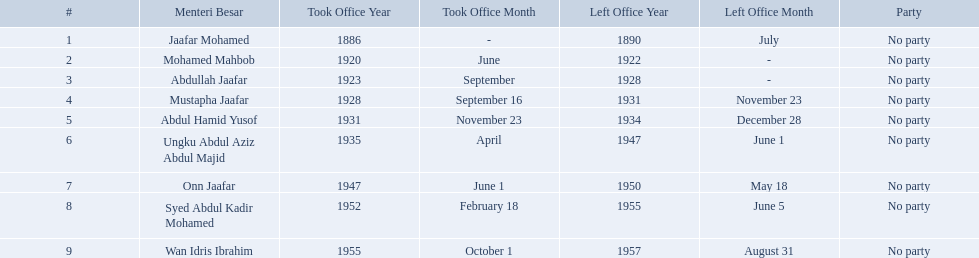Who were the menteri besar of johor? Jaafar Mohamed, Mohamed Mahbob, Abdullah Jaafar, Mustapha Jaafar, Abdul Hamid Yusof, Ungku Abdul Aziz Abdul Majid, Onn Jaafar, Syed Abdul Kadir Mohamed, Wan Idris Ibrahim. Who served the longest? Ungku Abdul Aziz Abdul Majid. Who are all of the menteri besars? Jaafar Mohamed, Mohamed Mahbob, Abdullah Jaafar, Mustapha Jaafar, Abdul Hamid Yusof, Ungku Abdul Aziz Abdul Majid, Onn Jaafar, Syed Abdul Kadir Mohamed, Wan Idris Ibrahim. When did each take office? 1886, June 1920, September 1923, September 16, 1928, November 23, 1931, April 1935, June 1, 1947, February 18, 1952, October 1, 1955. When did they leave? July 1890, 1922, 1928, November 23, 1931, December 28, 1934, June 1, 1947, May 18, 1950, June 5, 1955, August 31, 1957. And which spent the most time in office? Ungku Abdul Aziz Abdul Majid. When did jaafar mohamed take office? 1886. When did mohamed mahbob take office? June 1920. Who was in office no more than 4 years? Mohamed Mahbob. Who were all of the menteri besars? Jaafar Mohamed, Mohamed Mahbob, Abdullah Jaafar, Mustapha Jaafar, Abdul Hamid Yusof, Ungku Abdul Aziz Abdul Majid, Onn Jaafar, Syed Abdul Kadir Mohamed, Wan Idris Ibrahim. When did they take office? 1886, June 1920, September 1923, September 16, 1928, November 23, 1931, April 1935, June 1, 1947, February 18, 1952, October 1, 1955. And when did they leave? July 1890, 1922, 1928, November 23, 1931, December 28, 1934, June 1, 1947, May 18, 1950, June 5, 1955, August 31, 1957. Now, who was in office for less than four years? Mohamed Mahbob. 